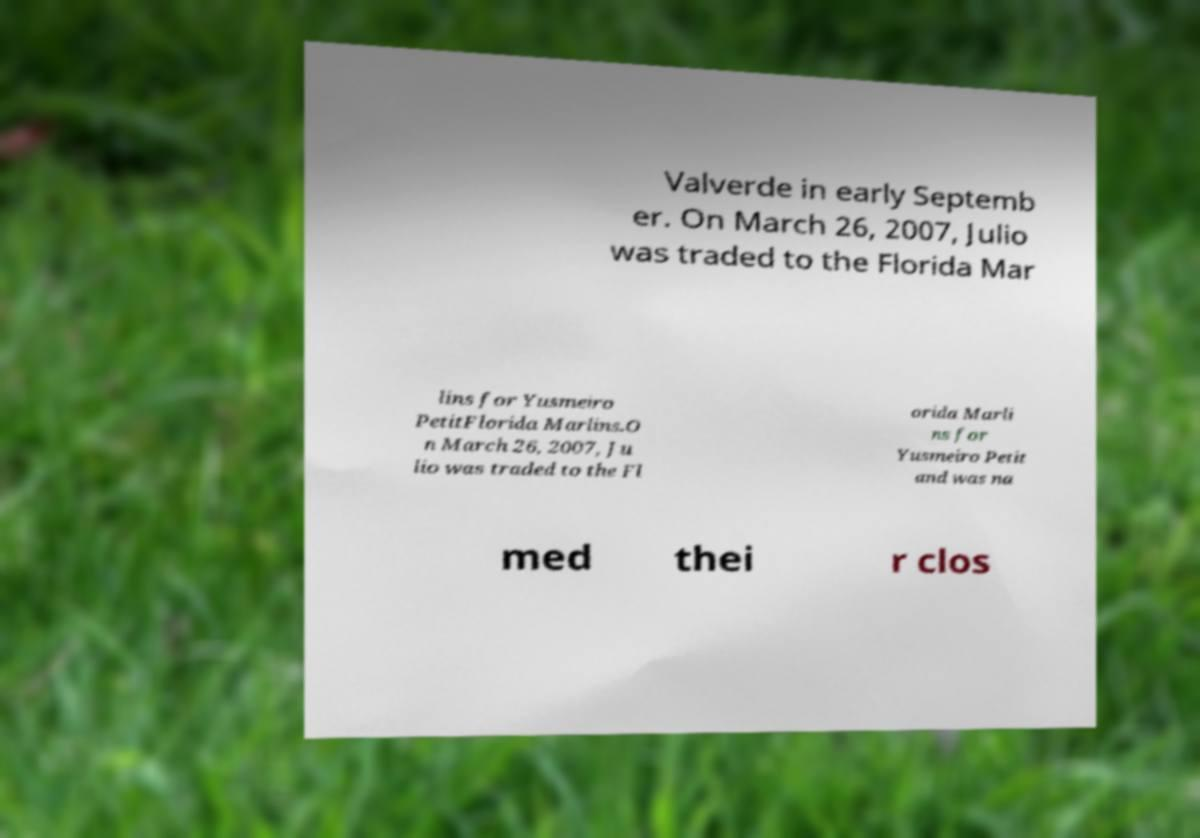What messages or text are displayed in this image? I need them in a readable, typed format. Valverde in early Septemb er. On March 26, 2007, Julio was traded to the Florida Mar lins for Yusmeiro PetitFlorida Marlins.O n March 26, 2007, Ju lio was traded to the Fl orida Marli ns for Yusmeiro Petit and was na med thei r clos 